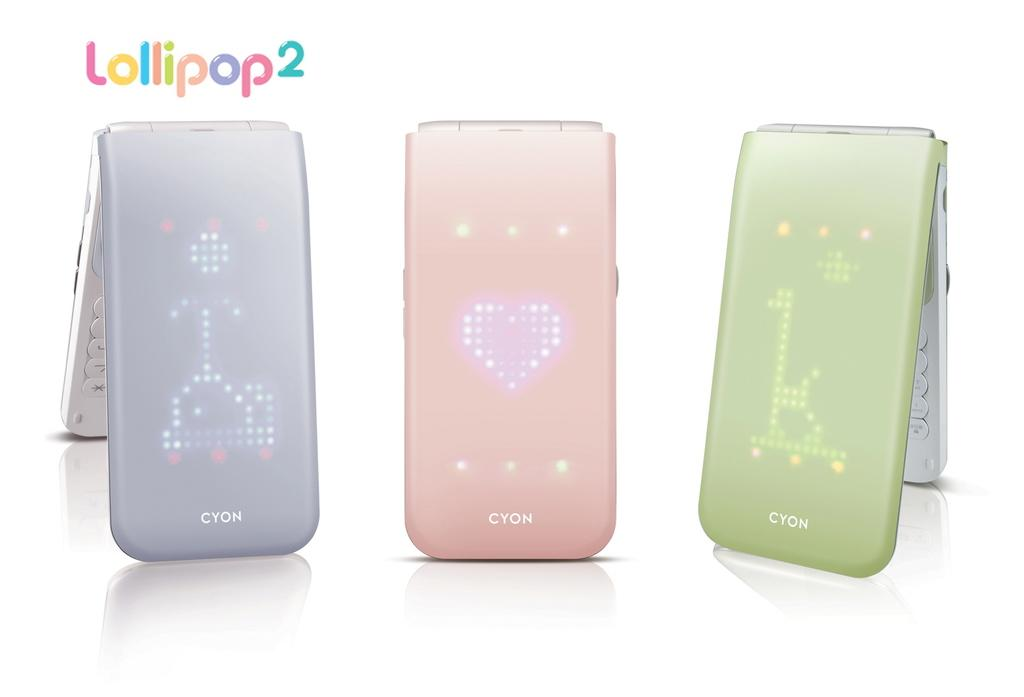<image>
Write a terse but informative summary of the picture. Purple, pink, and green Lollipop2 are standing side by side. . 